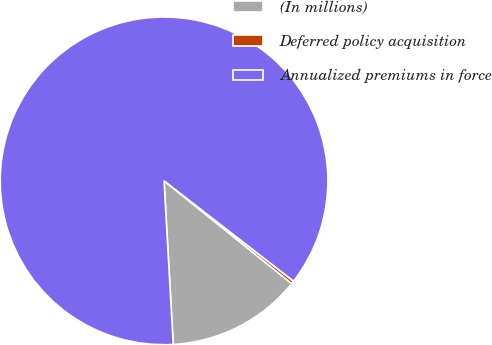Convert chart. <chart><loc_0><loc_0><loc_500><loc_500><pie_chart><fcel>(In millions)<fcel>Deferred policy acquisition<fcel>Annualized premiums in force<nl><fcel>13.32%<fcel>0.3%<fcel>86.39%<nl></chart> 